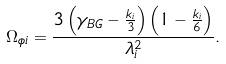<formula> <loc_0><loc_0><loc_500><loc_500>\Omega _ { \phi i } = \frac { 3 \left ( \gamma _ { B G } - \frac { k _ { i } } { 3 } \right ) \left ( 1 - \frac { k _ { i } } { 6 } \right ) } { \lambda ^ { 2 } _ { i } } .</formula> 